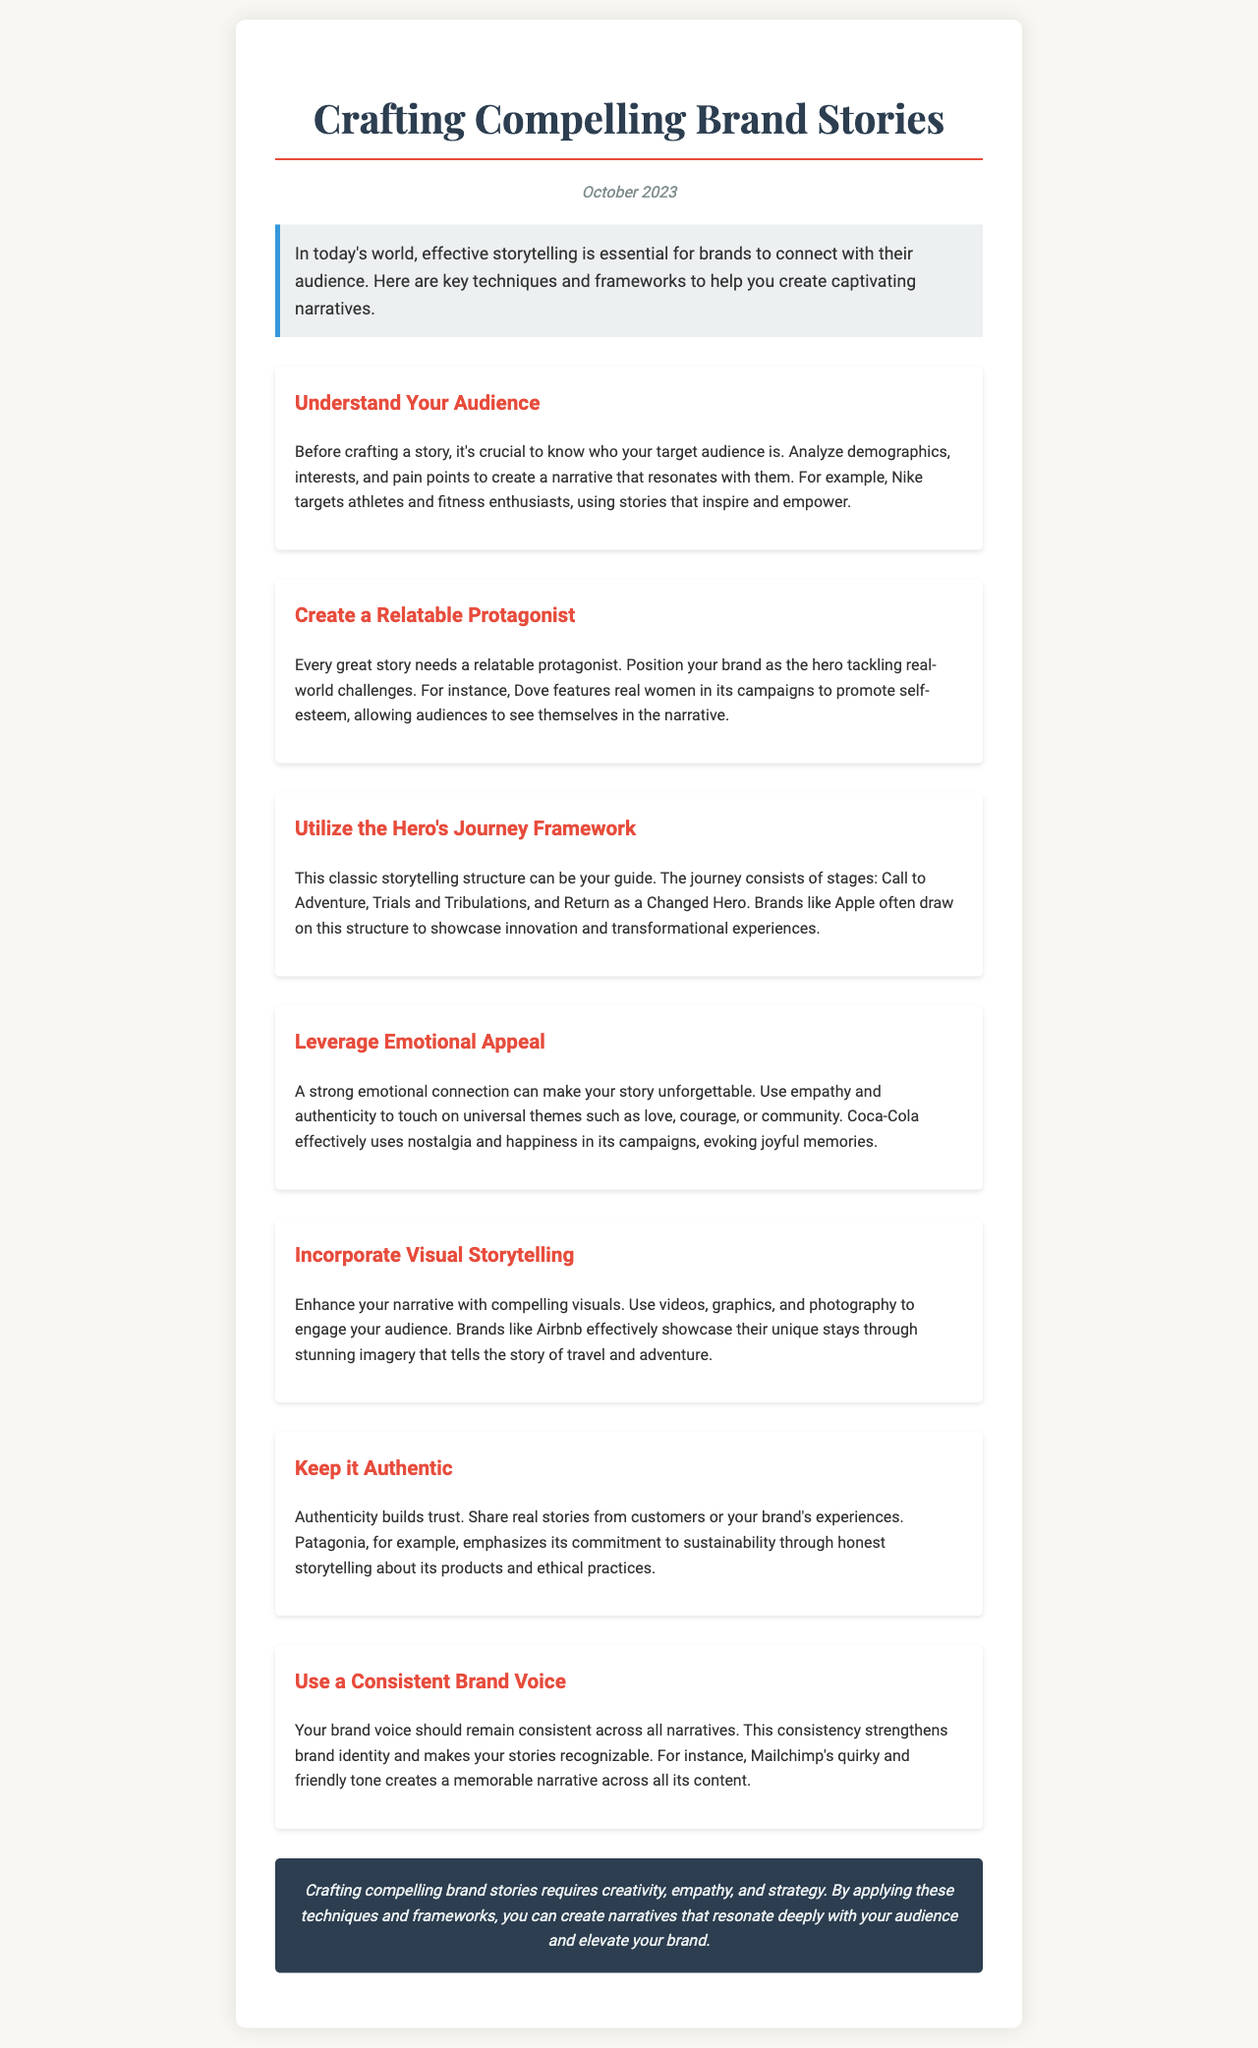What is the title of the newsletter? The title is prominently displayed at the top of the newsletter, indicating the main topic covered.
Answer: Crafting Compelling Brand Stories What date was the newsletter published? The publication date is mentioned in a specific paragraph to inform readers of its recency.
Answer: October 2023 What is a key technique for understanding the audience? The document provides useful tips, one of which centers on demographic analysis to engage effectively.
Answer: Analyze demographics Which brand is mentioned as an example of emotional appeal? An example is provided in the section discussing emotional connections with customers, illustrating successful branding.
Answer: Coca-Cola Which storytelling framework is suggested in the newsletter? The document outlines a widely recognized framework that guides the structure of effective storytelling.
Answer: Hero's Journey What is the primary focus of the introduction paragraph? The introduction summarizes the main aim of the newsletter and what it intends to offer the reader.
Answer: Effective storytelling What should be included to enhance narratives according to the tips? The tips section highlights specific methods to engage audiences more visually in storytelling efforts.
Answer: Compelling visuals What trait should a brand maintain across its narratives? The document emphasizes a particular aspect that helps in establishing the brand's identity effectively.
Answer: Consistent Brand Voice How many tips are provided in the newsletter? The number of tips can be determined by counting the individual sections dedicated to each method shared.
Answer: Seven 